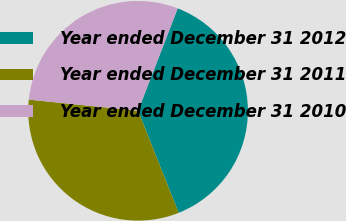<chart> <loc_0><loc_0><loc_500><loc_500><pie_chart><fcel>Year ended December 31 2012<fcel>Year ended December 31 2011<fcel>Year ended December 31 2010<nl><fcel>38.1%<fcel>32.65%<fcel>29.25%<nl></chart> 